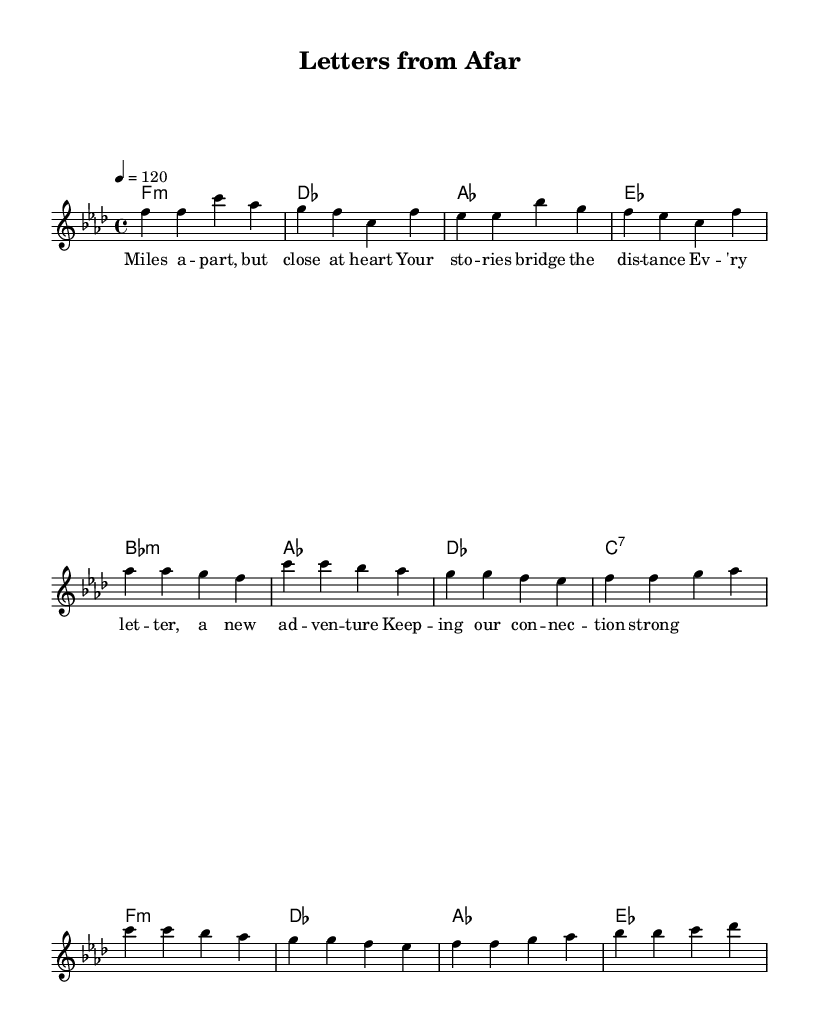What is the key signature of this music? The key signature is indicated at the beginning of the staff. In this case, it shows a B♭ and E♭, typical of F minor.
Answer: F minor What is the time signature of this music? The time signature is shown at the beginning of the score, represented by the numbers above the staff. Here, it is 4 over 4, meaning there are four beats per measure.
Answer: 4/4 What is the tempo marking for this piece? The tempo is noted within the score, written as a quarter note equals 120 beats per minute, giving a fast-paced, lively feel typical in house music.
Answer: 120 How many measures are there in the chorus section? The chorus consists of four lines of music, and each line contains one measure of four quarter notes, totaling four measures in the chorus section.
Answer: 4 What type of lyrics accompany this melody? By examining the text below the notes, the lyrics express themes of long-distance family connections and emotional bonds, suitable for soulful house music.
Answer: Long-distance family connections What is the structure of this piece? The piece follows a structure with a verse, a pre-chorus, and a chorus, commonly found in house music, creating a repetitive and engaging pattern.
Answer: Verse, Pre-Chorus, Chorus What mood does the harmony evoke? The harmony is constructed with minor chords and nurturing progressions, typical of soulful house music, creating a reflective and emotional mood while emphasizing the distance yet closeness of connections.
Answer: Reflective and emotional 